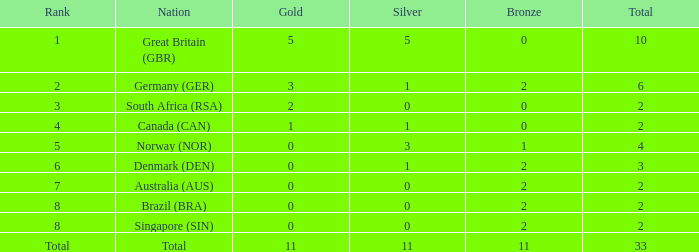What is the least total when the nation is canada (can) and bronze is less than 0? None. 